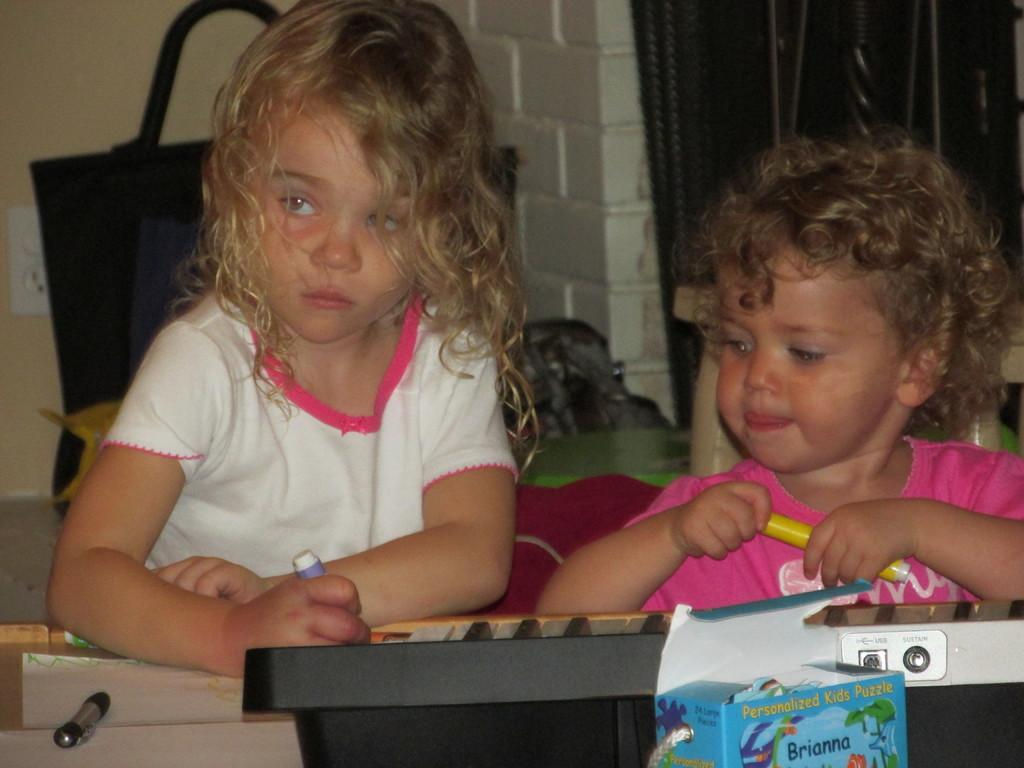How many children are present in the image? There are two children in the image. What are the children holding in their hands? The children are holding pens. Can you describe any other objects or features in the image? There is a cardboard box on the right side of the image. What type of knowledge can be gained from the acoustics of the spot in the image? There is no mention of acoustics or a spot in the image, so it is not possible to answer that question. 